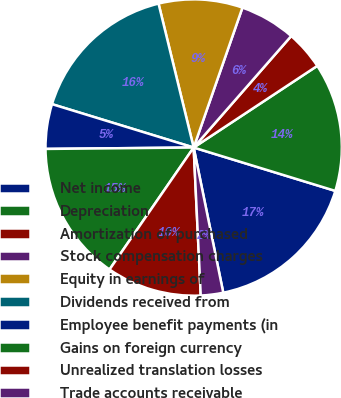Convert chart to OTSL. <chart><loc_0><loc_0><loc_500><loc_500><pie_chart><fcel>Net income<fcel>Depreciation<fcel>Amortization of purchased<fcel>Stock compensation charges<fcel>Equity in earnings of<fcel>Dividends received from<fcel>Employee benefit payments (in<fcel>Gains on foreign currency<fcel>Unrealized translation losses<fcel>Trade accounts receivable<nl><fcel>17.07%<fcel>14.02%<fcel>4.27%<fcel>6.1%<fcel>9.15%<fcel>16.46%<fcel>4.88%<fcel>15.24%<fcel>10.37%<fcel>2.44%<nl></chart> 